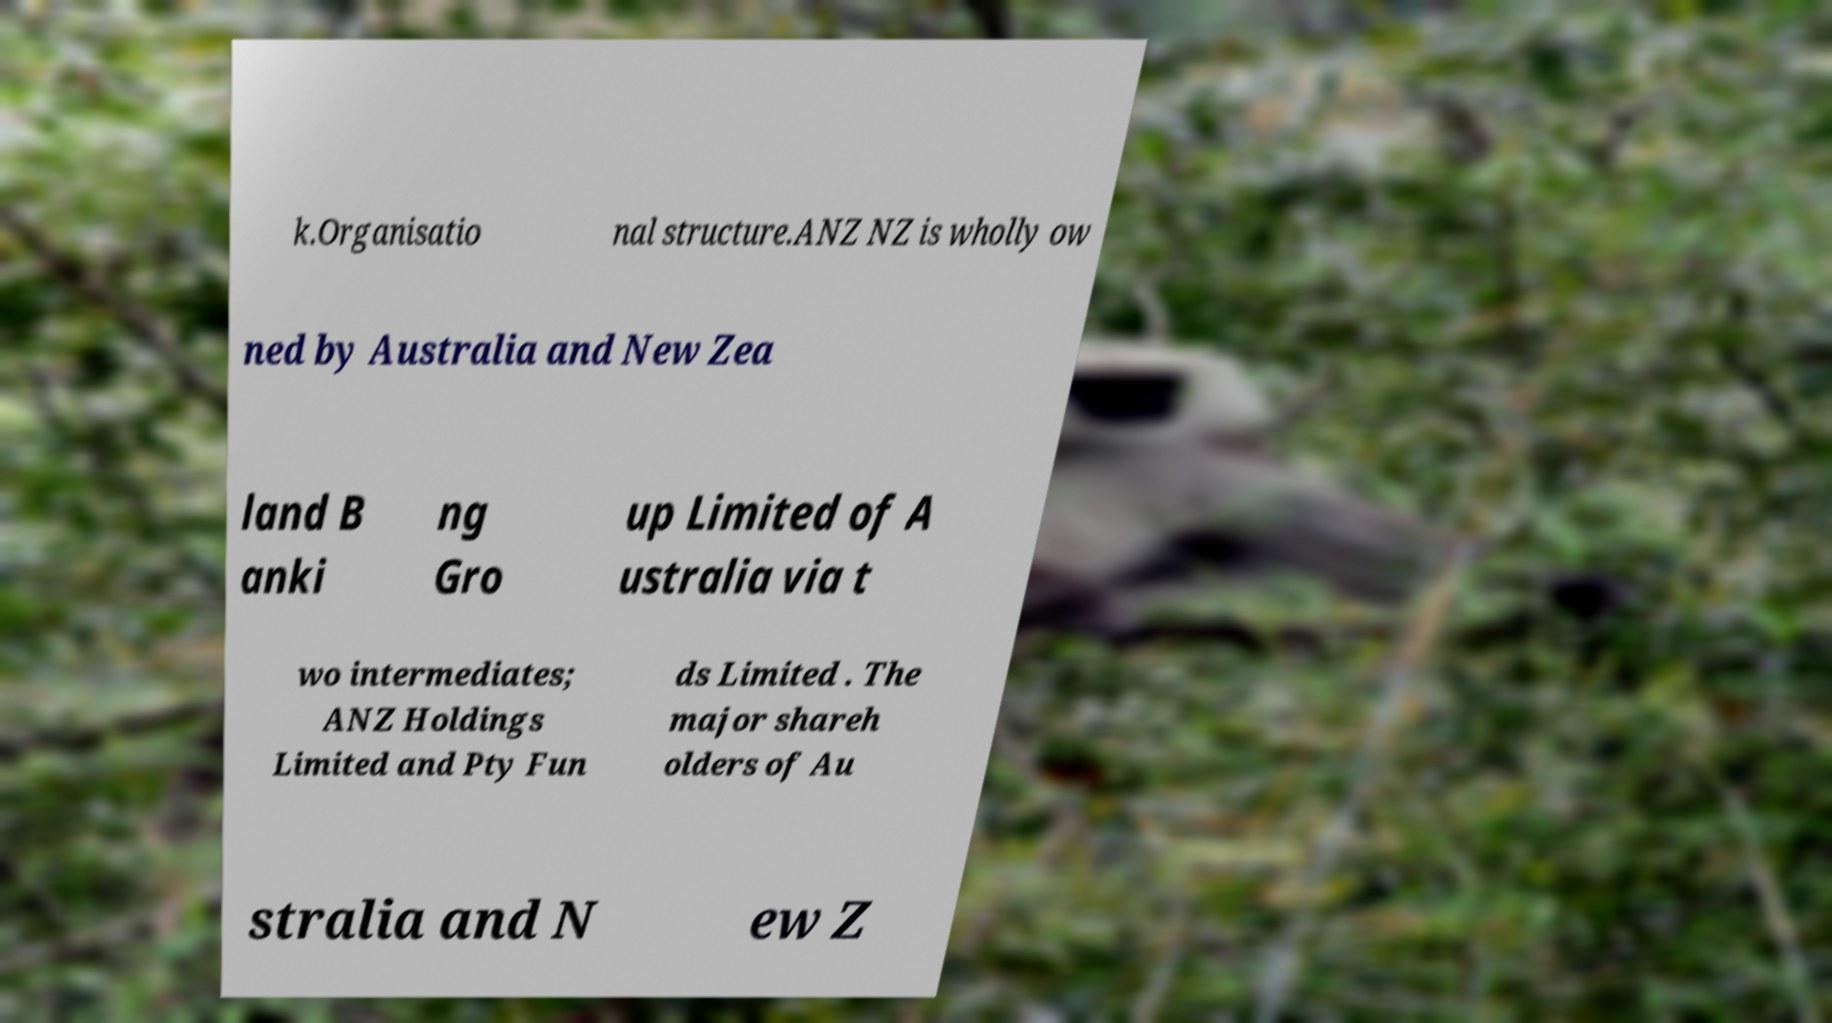Please read and relay the text visible in this image. What does it say? k.Organisatio nal structure.ANZ NZ is wholly ow ned by Australia and New Zea land B anki ng Gro up Limited of A ustralia via t wo intermediates; ANZ Holdings Limited and Pty Fun ds Limited . The major shareh olders of Au stralia and N ew Z 